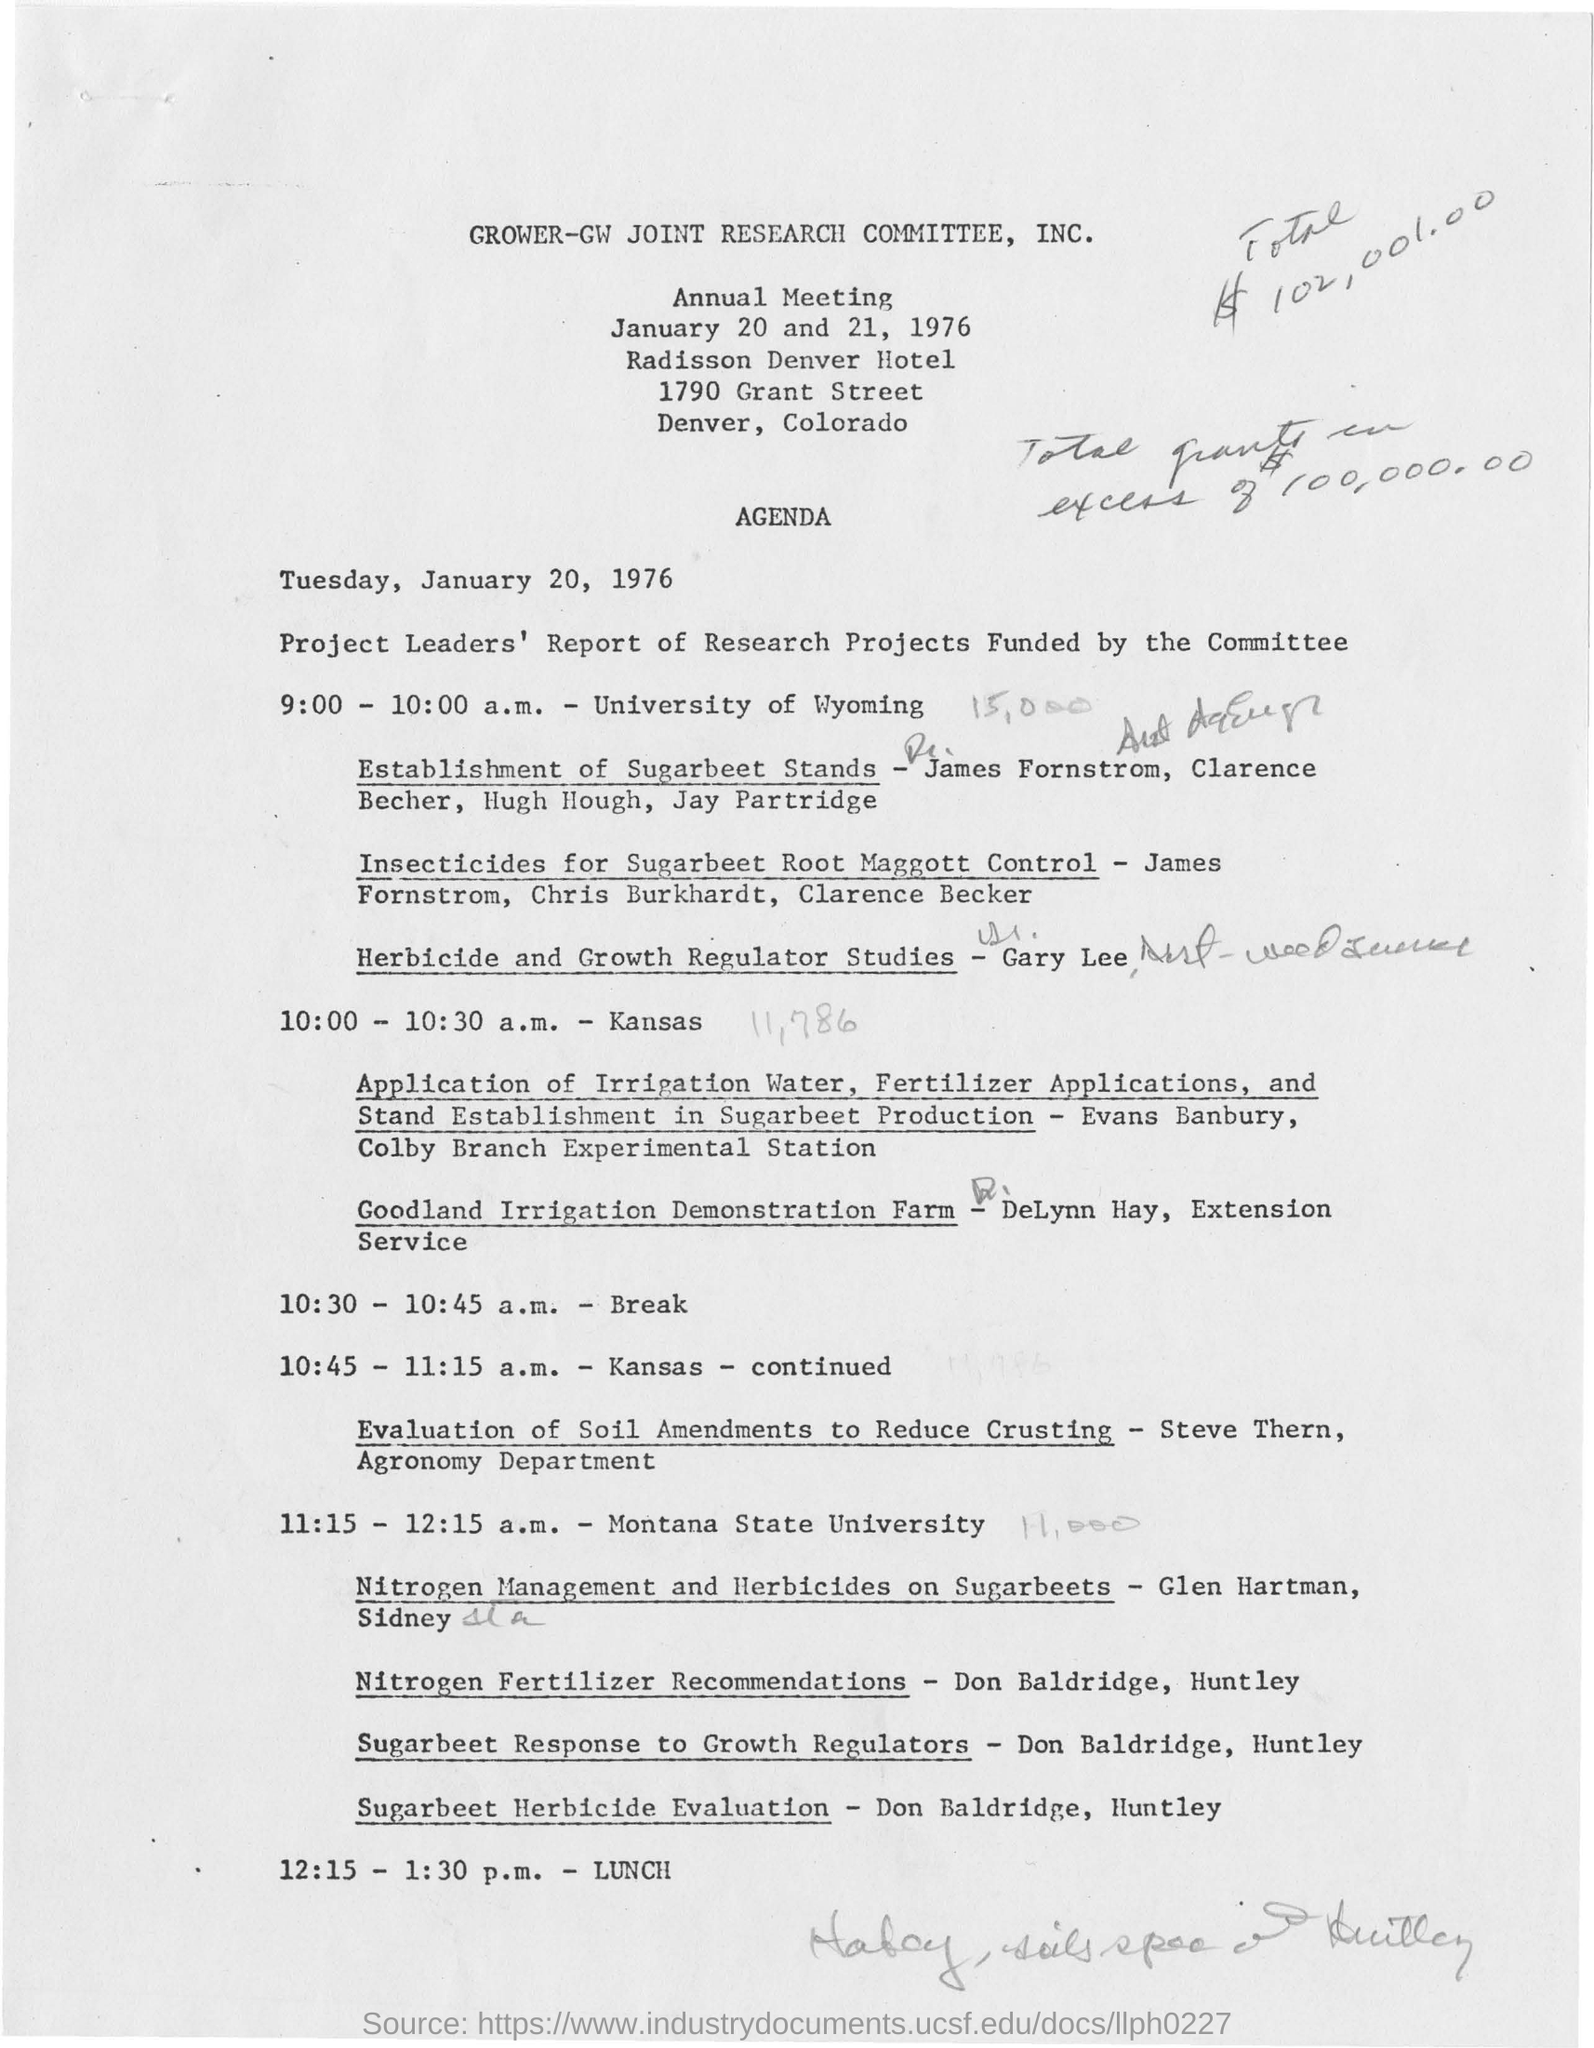Indicate a few pertinent items in this graphic. In Steve Tern's department, the field of study focuses on agronomy. On January 20 and 21, 1976, the GROWER-GW Joint Research Committee held its annual meeting. The annual meeting was held on January 20 and 21, 1976. The lunch time is from 12:15 to 1:30 p.m. 